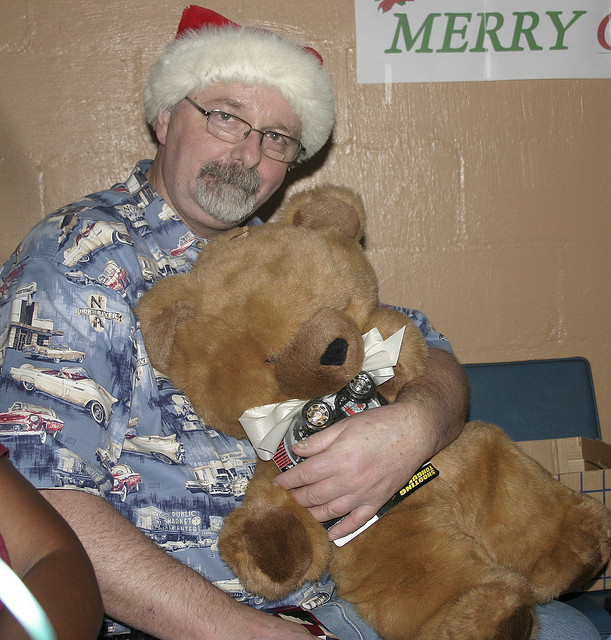Read and extract the text from this image. MERRY 